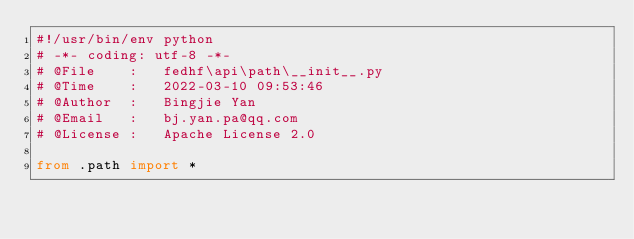<code> <loc_0><loc_0><loc_500><loc_500><_Python_>#!/usr/bin/env python
# -*- coding: utf-8 -*-
# @File    :   fedhf\api\path\__init__.py
# @Time    :   2022-03-10 09:53:46
# @Author  :   Bingjie Yan
# @Email   :   bj.yan.pa@qq.com
# @License :   Apache License 2.0

from .path import *</code> 